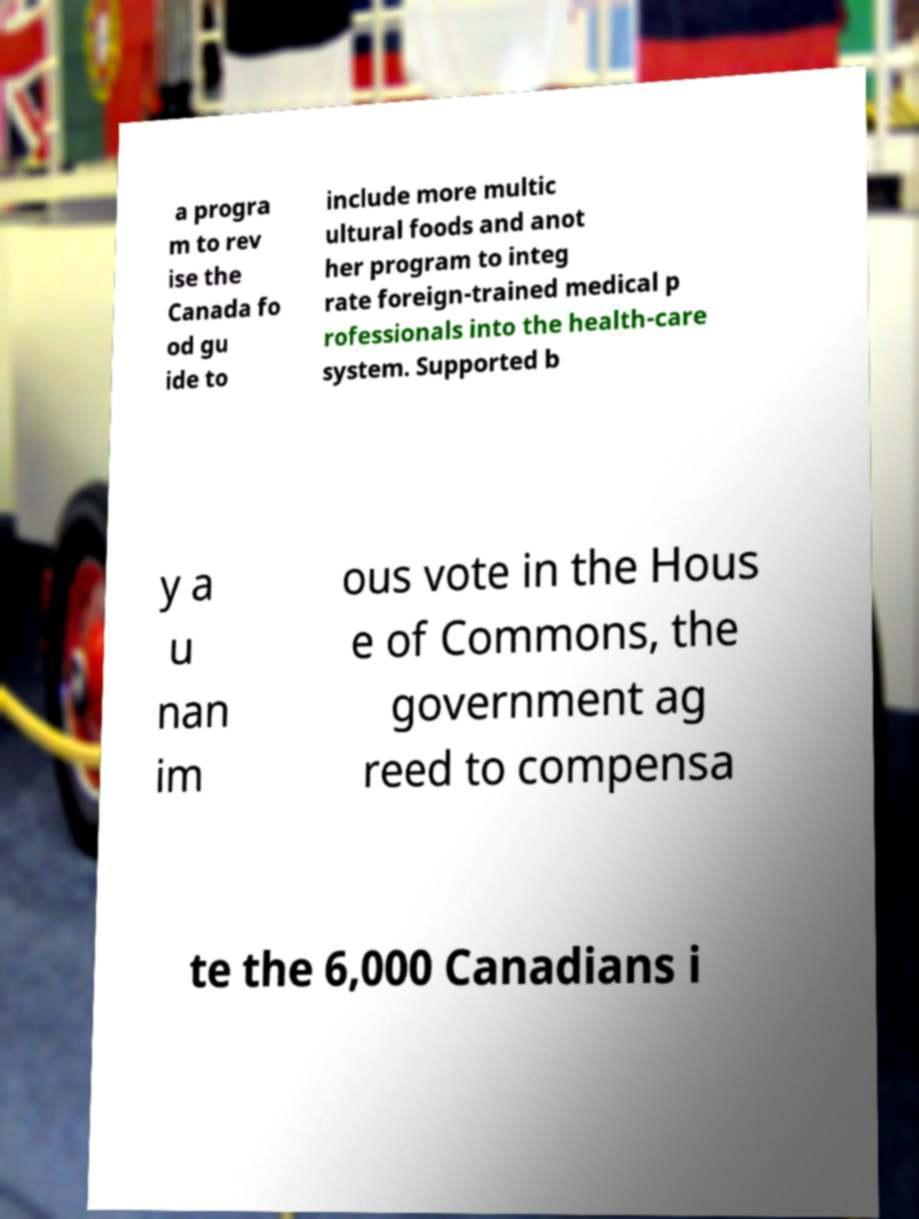There's text embedded in this image that I need extracted. Can you transcribe it verbatim? a progra m to rev ise the Canada fo od gu ide to include more multic ultural foods and anot her program to integ rate foreign-trained medical p rofessionals into the health-care system. Supported b y a u nan im ous vote in the Hous e of Commons, the government ag reed to compensa te the 6,000 Canadians i 